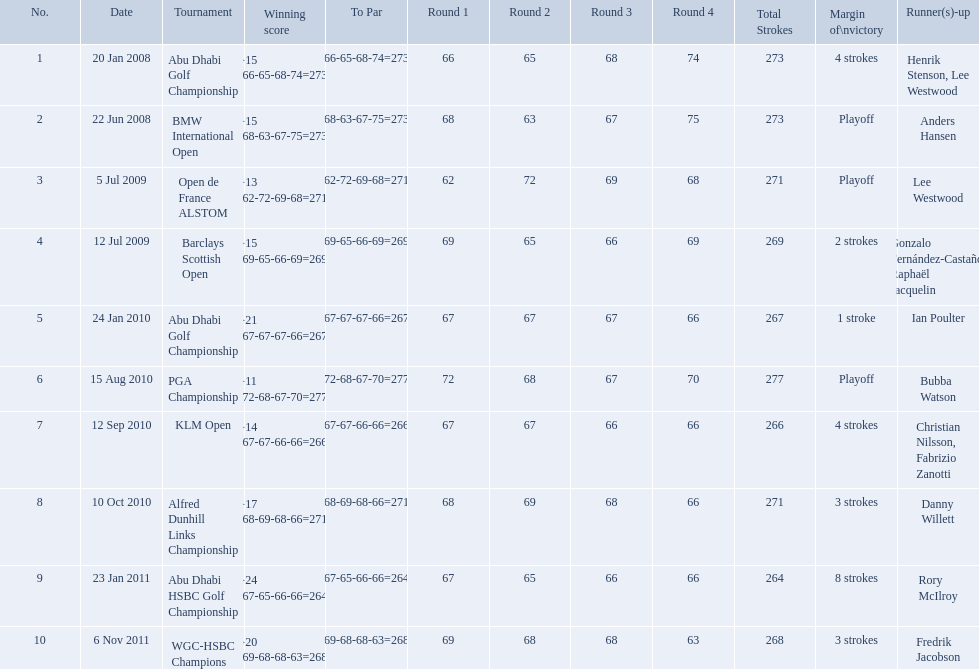What were all of the tournaments martin played in? Abu Dhabi Golf Championship, BMW International Open, Open de France ALSTOM, Barclays Scottish Open, Abu Dhabi Golf Championship, PGA Championship, KLM Open, Alfred Dunhill Links Championship, Abu Dhabi HSBC Golf Championship, WGC-HSBC Champions. And how many strokes did he score? −15 (66-65-68-74=273), −15 (68-63-67-75=273), −13 (62-72-69-68=271), −15 (69-65-66-69=269), −21 (67-67-67-66=267), −11 (72-68-67-70=277), −14 (67-67-66-66=266), −17 (68-69-68-66=271), −24 (67-65-66-66=264), −20 (69-68-68-63=268). What about during barclays and klm? −15 (69-65-66-69=269), −14 (67-67-66-66=266). How many more were scored in klm? 2 strokes. What were all the different tournaments played by martin kaymer Abu Dhabi Golf Championship, BMW International Open, Open de France ALSTOM, Barclays Scottish Open, Abu Dhabi Golf Championship, PGA Championship, KLM Open, Alfred Dunhill Links Championship, Abu Dhabi HSBC Golf Championship, WGC-HSBC Champions. Who was the runner-up for the pga championship? Bubba Watson. Which tournaments did martin kaymer participate in? Abu Dhabi Golf Championship, BMW International Open, Open de France ALSTOM, Barclays Scottish Open, Abu Dhabi Golf Championship, PGA Championship, KLM Open, Alfred Dunhill Links Championship, Abu Dhabi HSBC Golf Championship, WGC-HSBC Champions. How many of these tournaments were won through a playoff? BMW International Open, Open de France ALSTOM, PGA Championship. Which of those tournaments took place in 2010? PGA Championship. Who had to top score next to martin kaymer for that tournament? Bubba Watson. What are all of the tournaments? Abu Dhabi Golf Championship, BMW International Open, Open de France ALSTOM, Barclays Scottish Open, Abu Dhabi Golf Championship, PGA Championship, KLM Open, Alfred Dunhill Links Championship, Abu Dhabi HSBC Golf Championship, WGC-HSBC Champions. What was the score during each? −15 (66-65-68-74=273), −15 (68-63-67-75=273), −13 (62-72-69-68=271), −15 (69-65-66-69=269), −21 (67-67-67-66=267), −11 (72-68-67-70=277), −14 (67-67-66-66=266), −17 (68-69-68-66=271), −24 (67-65-66-66=264), −20 (69-68-68-63=268). And who was the runner-up in each? Henrik Stenson, Lee Westwood, Anders Hansen, Lee Westwood, Gonzalo Fernández-Castaño, Raphaël Jacquelin, Ian Poulter, Bubba Watson, Christian Nilsson, Fabrizio Zanotti, Danny Willett, Rory McIlroy, Fredrik Jacobson. What about just during pga games? Bubba Watson. 